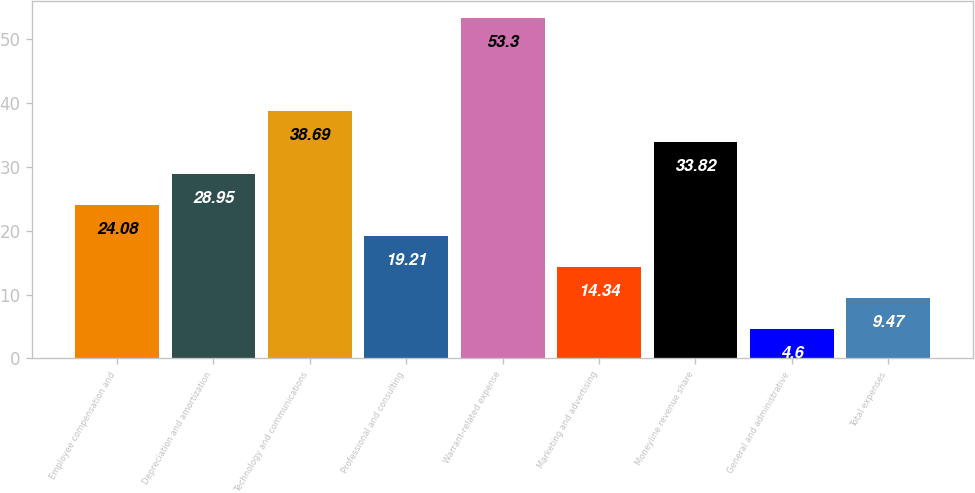<chart> <loc_0><loc_0><loc_500><loc_500><bar_chart><fcel>Employee compensation and<fcel>Depreciation and amortization<fcel>Technology and communications<fcel>Professional and consulting<fcel>Warrant-related expense<fcel>Marketing and advertising<fcel>Moneyline revenue share<fcel>General and administrative<fcel>Total expenses<nl><fcel>24.08<fcel>28.95<fcel>38.69<fcel>19.21<fcel>53.3<fcel>14.34<fcel>33.82<fcel>4.6<fcel>9.47<nl></chart> 